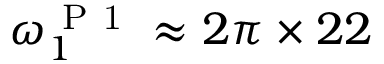Convert formula to latex. <formula><loc_0><loc_0><loc_500><loc_500>\omega _ { 1 } ^ { P 1 } \approx 2 \pi \times 2 2</formula> 